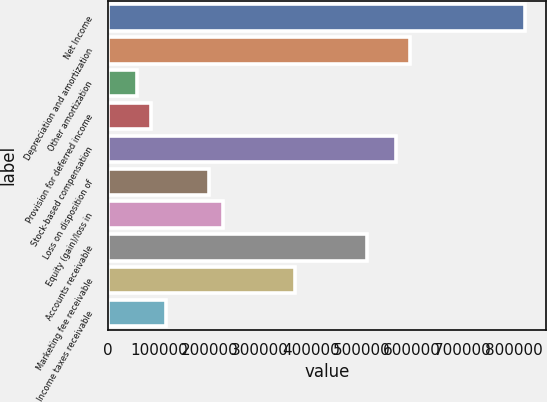<chart> <loc_0><loc_0><loc_500><loc_500><bar_chart><fcel>Net Income<fcel>Depreciation and amortization<fcel>Other amortization<fcel>Provision for deferred income<fcel>Stock-based compensation<fcel>Loss on disposition of<fcel>Equity (gain)/loss in<fcel>Accounts receivable<fcel>Marketing fee receivable<fcel>Income taxes receivable<nl><fcel>823400<fcel>596256<fcel>56789<fcel>85182<fcel>567863<fcel>198754<fcel>227147<fcel>511077<fcel>369112<fcel>113575<nl></chart> 